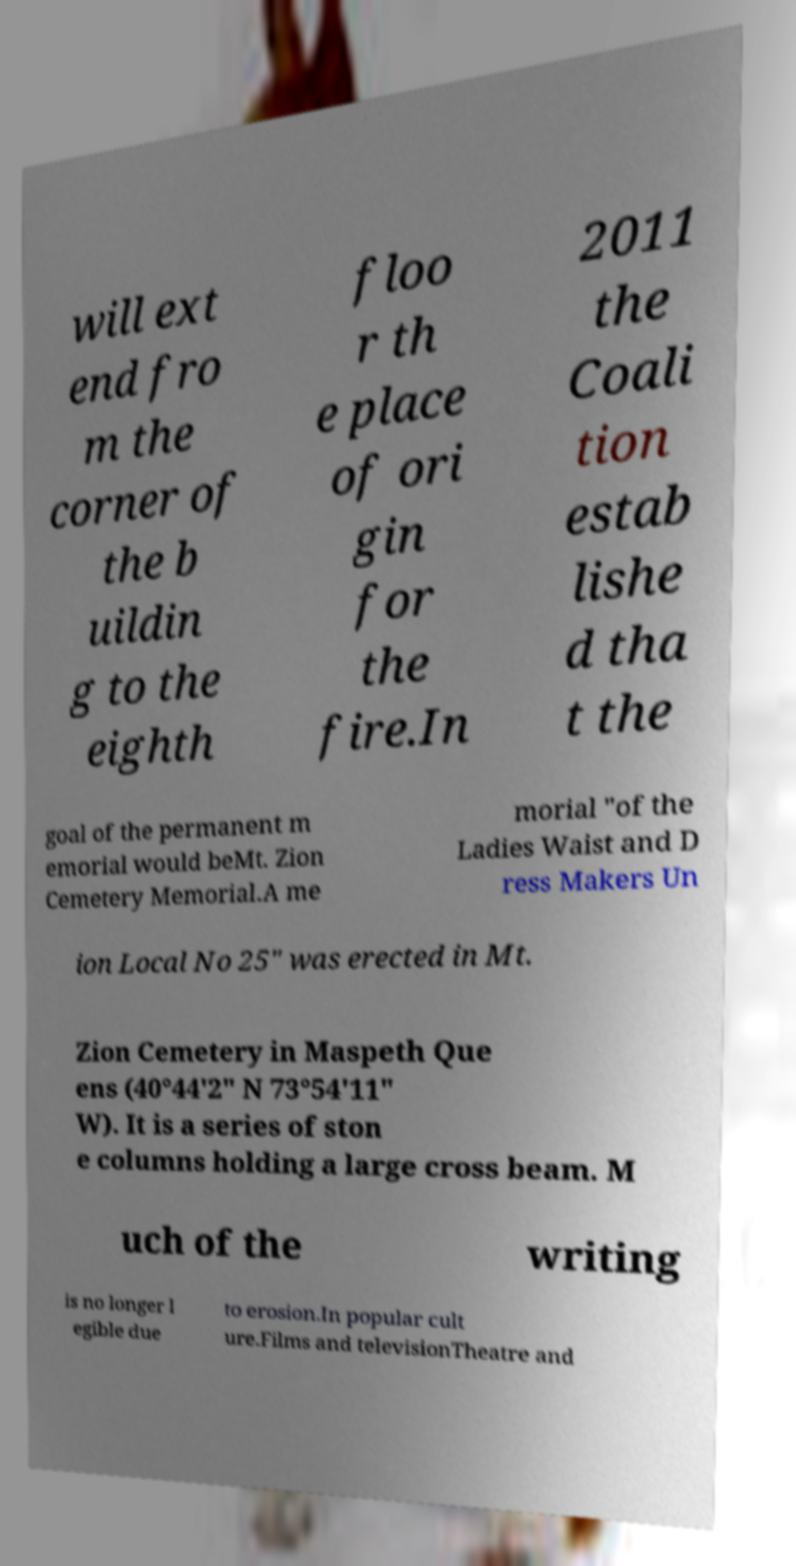Could you assist in decoding the text presented in this image and type it out clearly? will ext end fro m the corner of the b uildin g to the eighth floo r th e place of ori gin for the fire.In 2011 the Coali tion estab lishe d tha t the goal of the permanent m emorial would beMt. Zion Cemetery Memorial.A me morial "of the Ladies Waist and D ress Makers Un ion Local No 25" was erected in Mt. Zion Cemetery in Maspeth Que ens (40°44'2" N 73°54'11" W). It is a series of ston e columns holding a large cross beam. M uch of the writing is no longer l egible due to erosion.In popular cult ure.Films and televisionTheatre and 